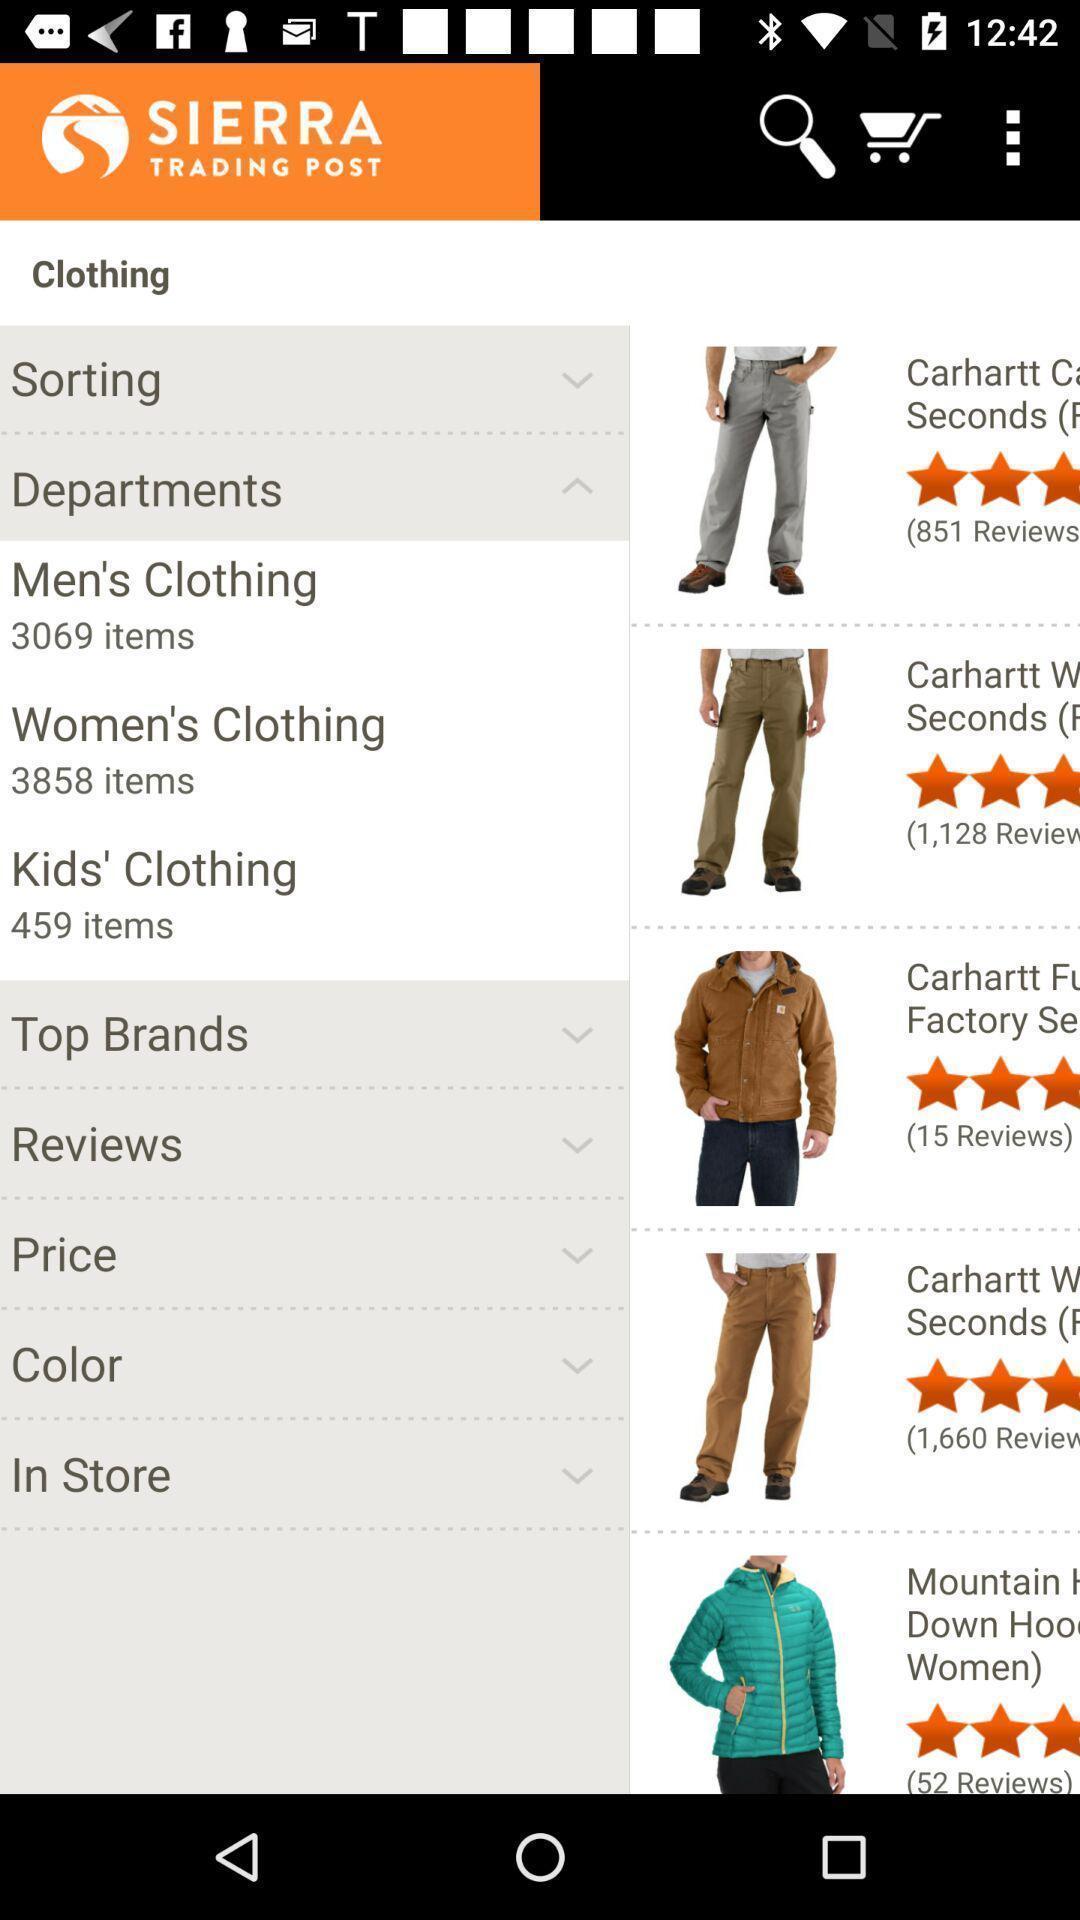Describe this image in words. Page of an shopping application with options. 